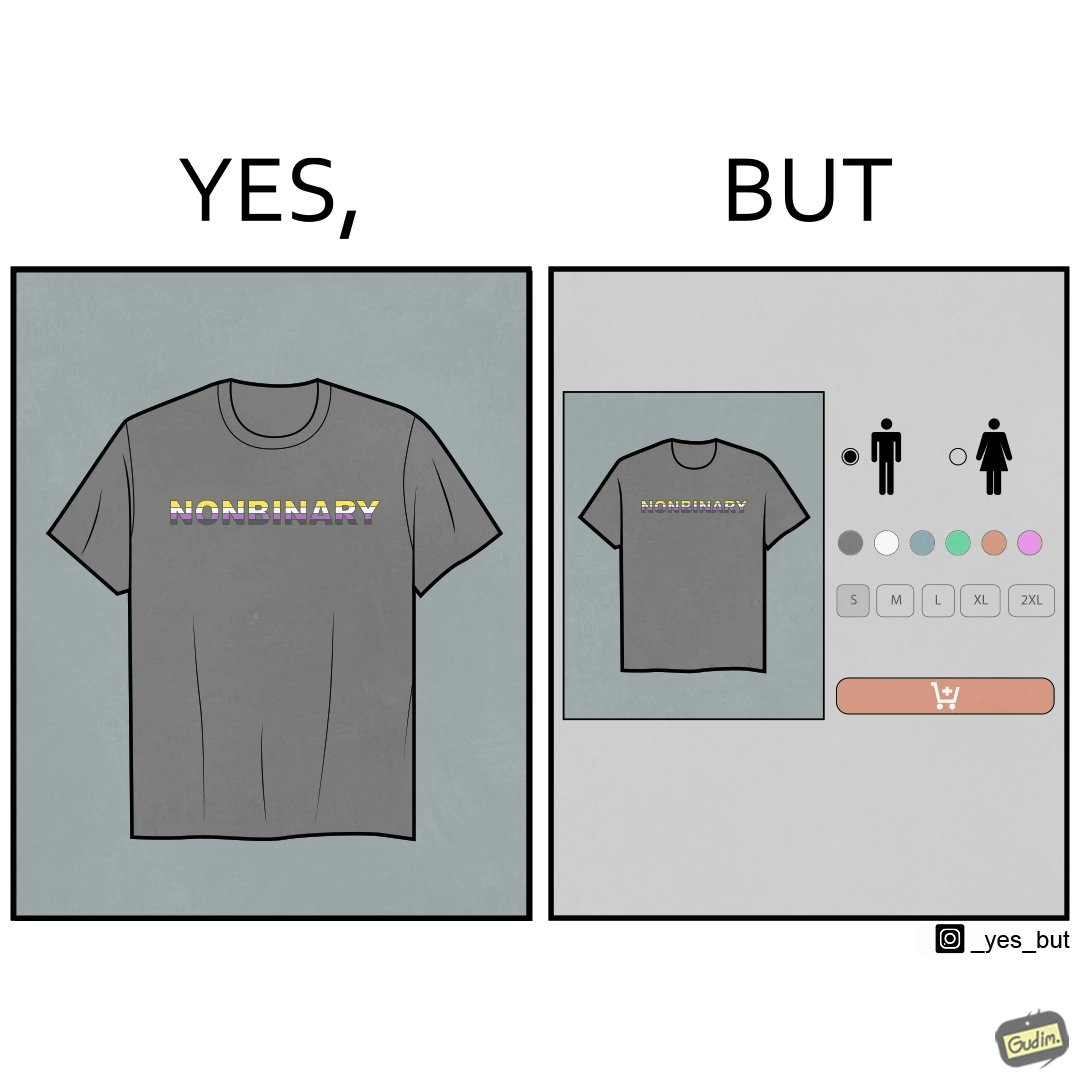Is there satirical content in this image? Yes, this image is satirical. 